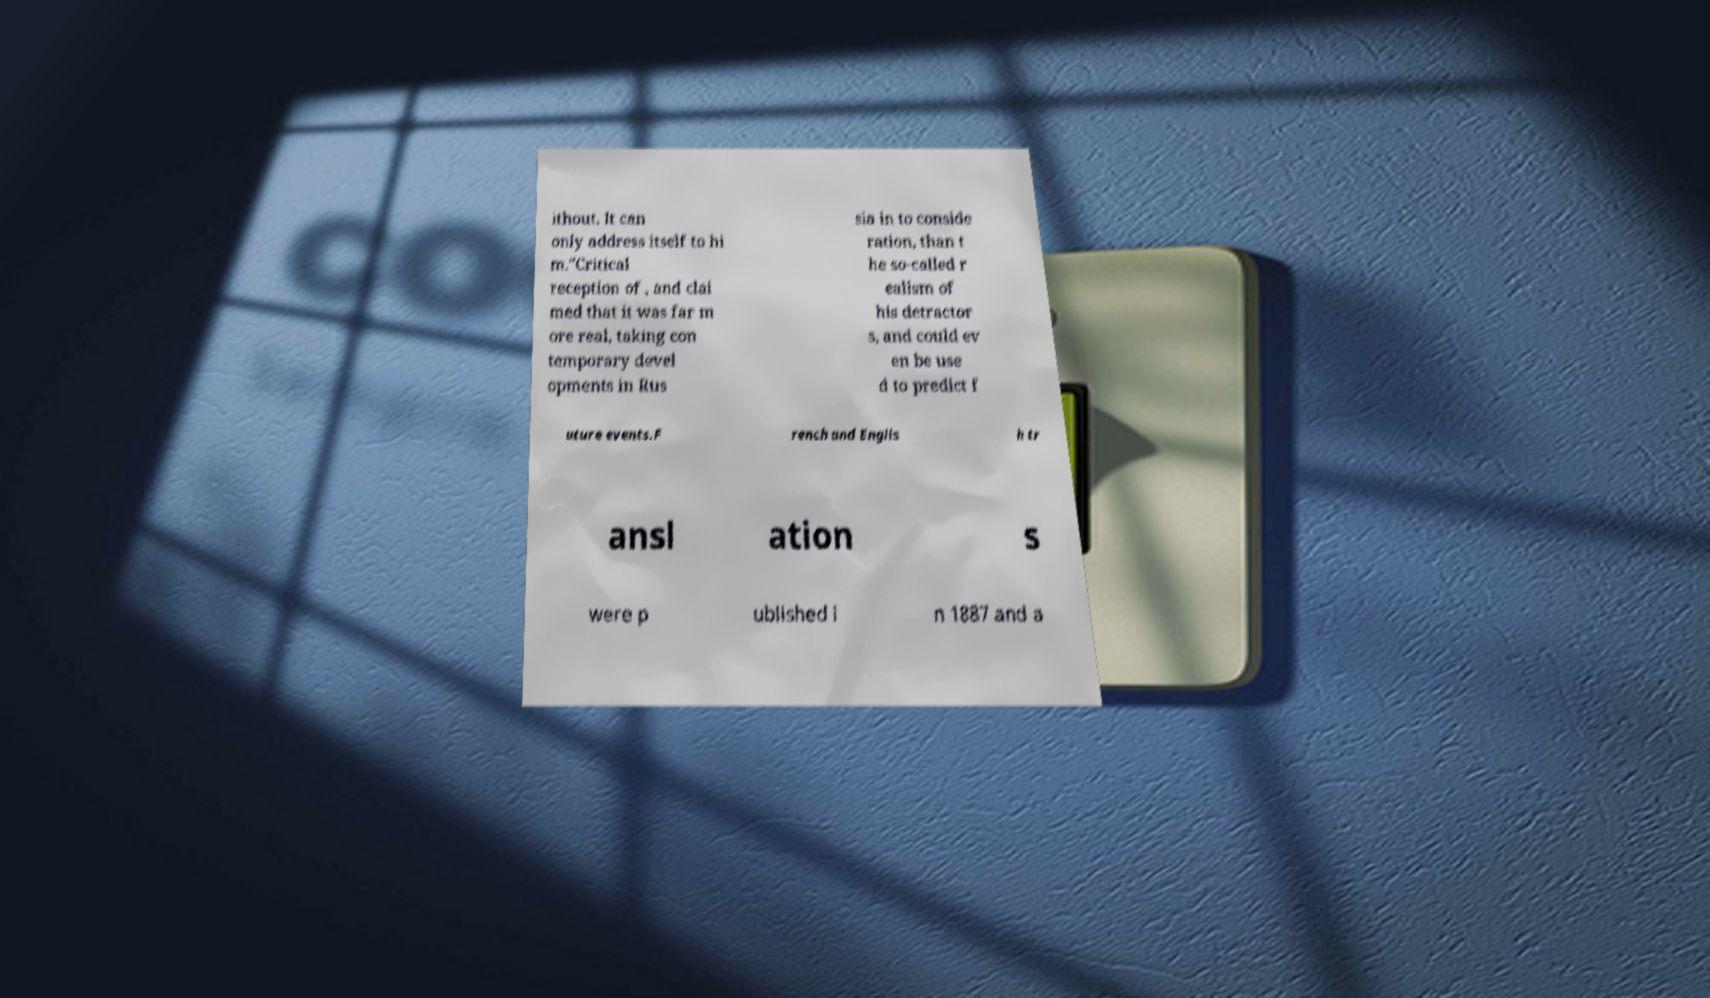What messages or text are displayed in this image? I need them in a readable, typed format. ithout. It can only address itself to hi m."Critical reception of , and clai med that it was far m ore real, taking con temporary devel opments in Rus sia in to conside ration, than t he so-called r ealism of his detractor s, and could ev en be use d to predict f uture events.F rench and Englis h tr ansl ation s were p ublished i n 1887 and a 